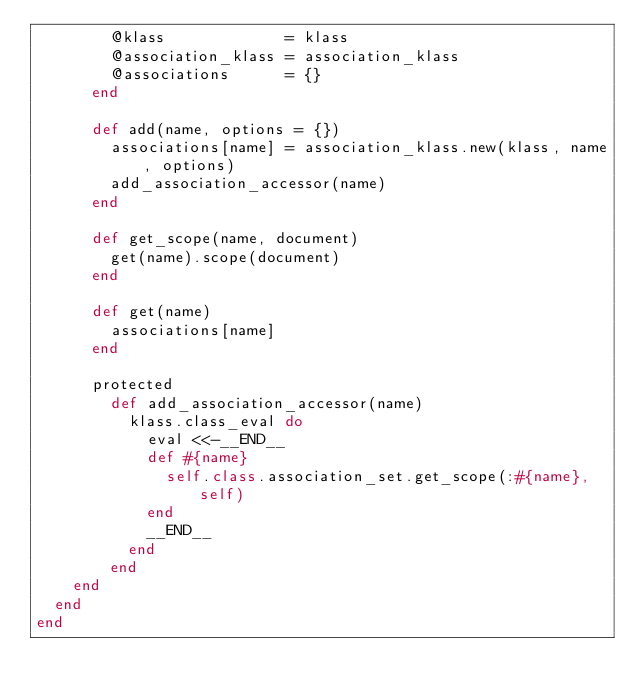Convert code to text. <code><loc_0><loc_0><loc_500><loc_500><_Ruby_>        @klass             = klass
        @association_klass = association_klass
        @associations      = {}
      end

      def add(name, options = {})
        associations[name] = association_klass.new(klass, name, options)
        add_association_accessor(name)
      end

      def get_scope(name, document)
        get(name).scope(document)
      end

      def get(name)
        associations[name]
      end

      protected
        def add_association_accessor(name)
          klass.class_eval do
            eval <<-__END__
            def #{name}
              self.class.association_set.get_scope(:#{name}, self)
            end
            __END__
          end
        end
    end
  end
end
</code> 